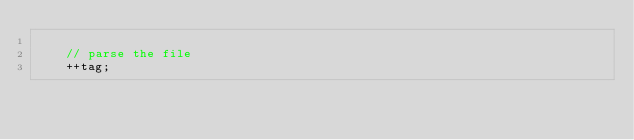<code> <loc_0><loc_0><loc_500><loc_500><_C++_>
		// parse the file
		++tag;
</code> 